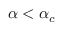<formula> <loc_0><loc_0><loc_500><loc_500>\alpha < \alpha _ { c }</formula> 